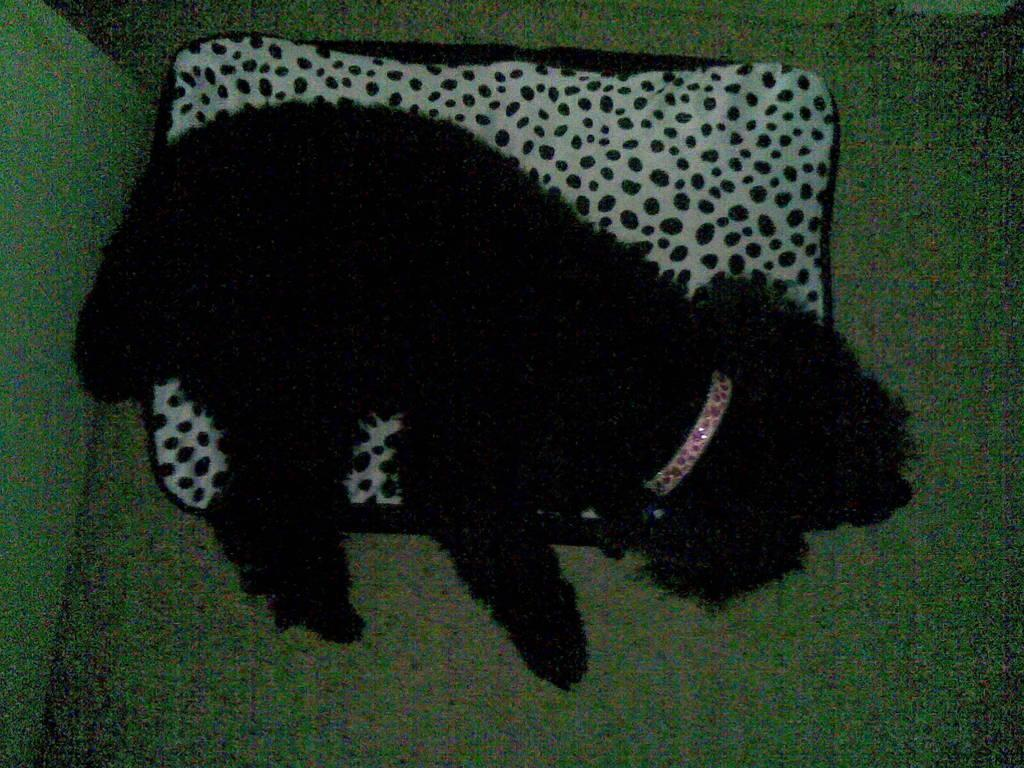What type of animal can be seen in the image? There is a black animal in the image. What is the animal doing in the image? The animal is laying on a pillow. What part of the room is visible in the image? The floor is visible in the image. What is the background of the image composed of? There is a wall in the image. How much money is being exchanged between the animal and the wall in the image? There is no money or exchange of payment depicted in the image; it only shows a black animal laying on a pillow with a visible wall in the background. 